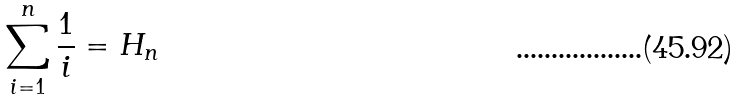Convert formula to latex. <formula><loc_0><loc_0><loc_500><loc_500>\sum _ { i = 1 } ^ { n } { \frac { 1 } { i } } = H _ { n }</formula> 